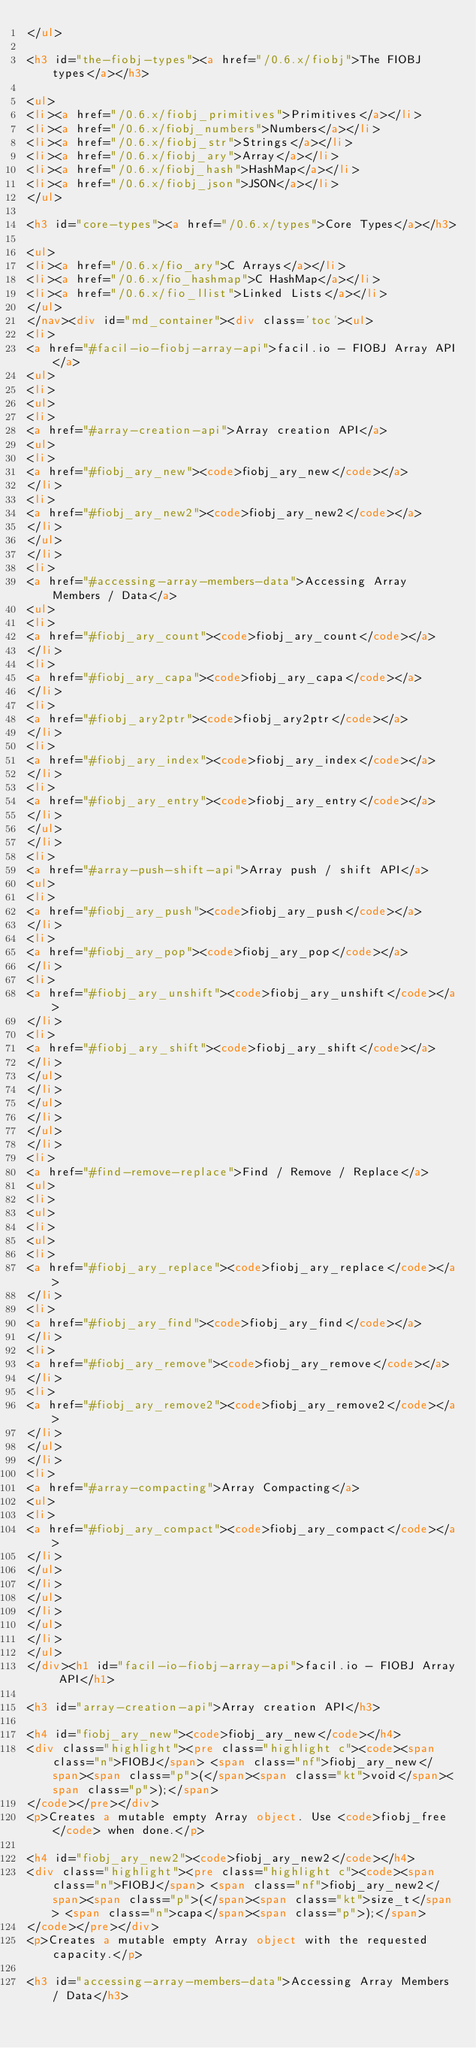Convert code to text. <code><loc_0><loc_0><loc_500><loc_500><_HTML_></ul>

<h3 id="the-fiobj-types"><a href="/0.6.x/fiobj">The FIOBJ types</a></h3>

<ul>
<li><a href="/0.6.x/fiobj_primitives">Primitives</a></li>
<li><a href="/0.6.x/fiobj_numbers">Numbers</a></li>
<li><a href="/0.6.x/fiobj_str">Strings</a></li>
<li><a href="/0.6.x/fiobj_ary">Array</a></li>
<li><a href="/0.6.x/fiobj_hash">HashMap</a></li>
<li><a href="/0.6.x/fiobj_json">JSON</a></li>
</ul>

<h3 id="core-types"><a href="/0.6.x/types">Core Types</a></h3>

<ul>
<li><a href="/0.6.x/fio_ary">C Arrays</a></li>
<li><a href="/0.6.x/fio_hashmap">C HashMap</a></li>
<li><a href="/0.6.x/fio_llist">Linked Lists</a></li>
</ul>
</nav><div id="md_container"><div class='toc'><ul>
<li>
<a href="#facil-io-fiobj-array-api">facil.io - FIOBJ Array API</a>
<ul>
<li>
<ul>
<li>
<a href="#array-creation-api">Array creation API</a>
<ul>
<li>
<a href="#fiobj_ary_new"><code>fiobj_ary_new</code></a>
</li>
<li>
<a href="#fiobj_ary_new2"><code>fiobj_ary_new2</code></a>
</li>
</ul>
</li>
<li>
<a href="#accessing-array-members-data">Accessing Array Members / Data</a>
<ul>
<li>
<a href="#fiobj_ary_count"><code>fiobj_ary_count</code></a>
</li>
<li>
<a href="#fiobj_ary_capa"><code>fiobj_ary_capa</code></a>
</li>
<li>
<a href="#fiobj_ary2ptr"><code>fiobj_ary2ptr</code></a>
</li>
<li>
<a href="#fiobj_ary_index"><code>fiobj_ary_index</code></a>
</li>
<li>
<a href="#fiobj_ary_entry"><code>fiobj_ary_entry</code></a>
</li>
</ul>
</li>
<li>
<a href="#array-push-shift-api">Array push / shift API</a>
<ul>
<li>
<a href="#fiobj_ary_push"><code>fiobj_ary_push</code></a>
</li>
<li>
<a href="#fiobj_ary_pop"><code>fiobj_ary_pop</code></a>
</li>
<li>
<a href="#fiobj_ary_unshift"><code>fiobj_ary_unshift</code></a>
</li>
<li>
<a href="#fiobj_ary_shift"><code>fiobj_ary_shift</code></a>
</li>
</ul>
</li>
</ul>
</li>
</ul>
</li>
<li>
<a href="#find-remove-replace">Find / Remove / Replace</a>
<ul>
<li>
<ul>
<li>
<ul>
<li>
<a href="#fiobj_ary_replace"><code>fiobj_ary_replace</code></a>
</li>
<li>
<a href="#fiobj_ary_find"><code>fiobj_ary_find</code></a>
</li>
<li>
<a href="#fiobj_ary_remove"><code>fiobj_ary_remove</code></a>
</li>
<li>
<a href="#fiobj_ary_remove2"><code>fiobj_ary_remove2</code></a>
</li>
</ul>
</li>
<li>
<a href="#array-compacting">Array Compacting</a>
<ul>
<li>
<a href="#fiobj_ary_compact"><code>fiobj_ary_compact</code></a>
</li>
</ul>
</li>
</ul>
</li>
</ul>
</li>
</ul>
</div><h1 id="facil-io-fiobj-array-api">facil.io - FIOBJ Array API</h1>

<h3 id="array-creation-api">Array creation API</h3>

<h4 id="fiobj_ary_new"><code>fiobj_ary_new</code></h4>
<div class="highlight"><pre class="highlight c"><code><span class="n">FIOBJ</span> <span class="nf">fiobj_ary_new</span><span class="p">(</span><span class="kt">void</span><span class="p">);</span>
</code></pre></div>
<p>Creates a mutable empty Array object. Use <code>fiobj_free</code> when done.</p>

<h4 id="fiobj_ary_new2"><code>fiobj_ary_new2</code></h4>
<div class="highlight"><pre class="highlight c"><code><span class="n">FIOBJ</span> <span class="nf">fiobj_ary_new2</span><span class="p">(</span><span class="kt">size_t</span> <span class="n">capa</span><span class="p">);</span>
</code></pre></div>
<p>Creates a mutable empty Array object with the requested capacity.</p>

<h3 id="accessing-array-members-data">Accessing Array Members / Data</h3>
</code> 